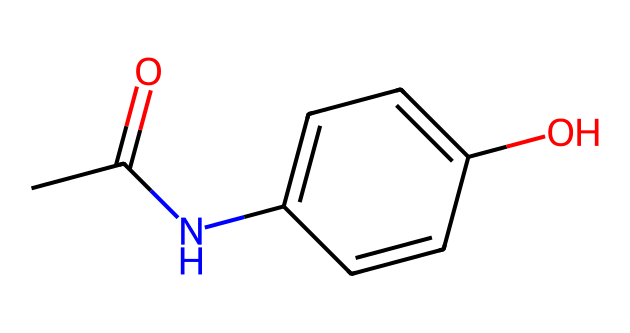What is the molecular formula of acetaminophen? To find the molecular formula, count each type of atom in the provided SMILES representation. There are 8 carbon atoms (C), 9 hydrogen atoms (H), 1 nitrogen atom (N), and 2 oxygen atoms (O). This gives us the molecular formula C8H9NO2.
Answer: C8H9NO2 How many rings are present in the chemical structure? In the SMILES representation, the 'C1' indicates the start of a ring and the corresponding 'C' later closes this ring. Upon inspecting, there is one ring in the structure.
Answer: 1 What functional groups are present in acetaminophen? By analyzing the structure, we can identify the functional groups. The structure contains an amide group (due to the 'NC' part) and a hydroxyl group (the '-OH' part). Therefore, there are two functional groups present.
Answer: 2 Is acetaminophen a solid at room temperature? Acetaminophen is known to have a crystalline solid state at room temperature, commonly used in tablet form.
Answer: Yes What is the predominant type of bonding in acetaminophen? This compound primarily exhibits covalent bonding, indicated by shared electrons between the atoms, particularly in the carbon and nitrogen connections in the structure.
Answer: Covalent 